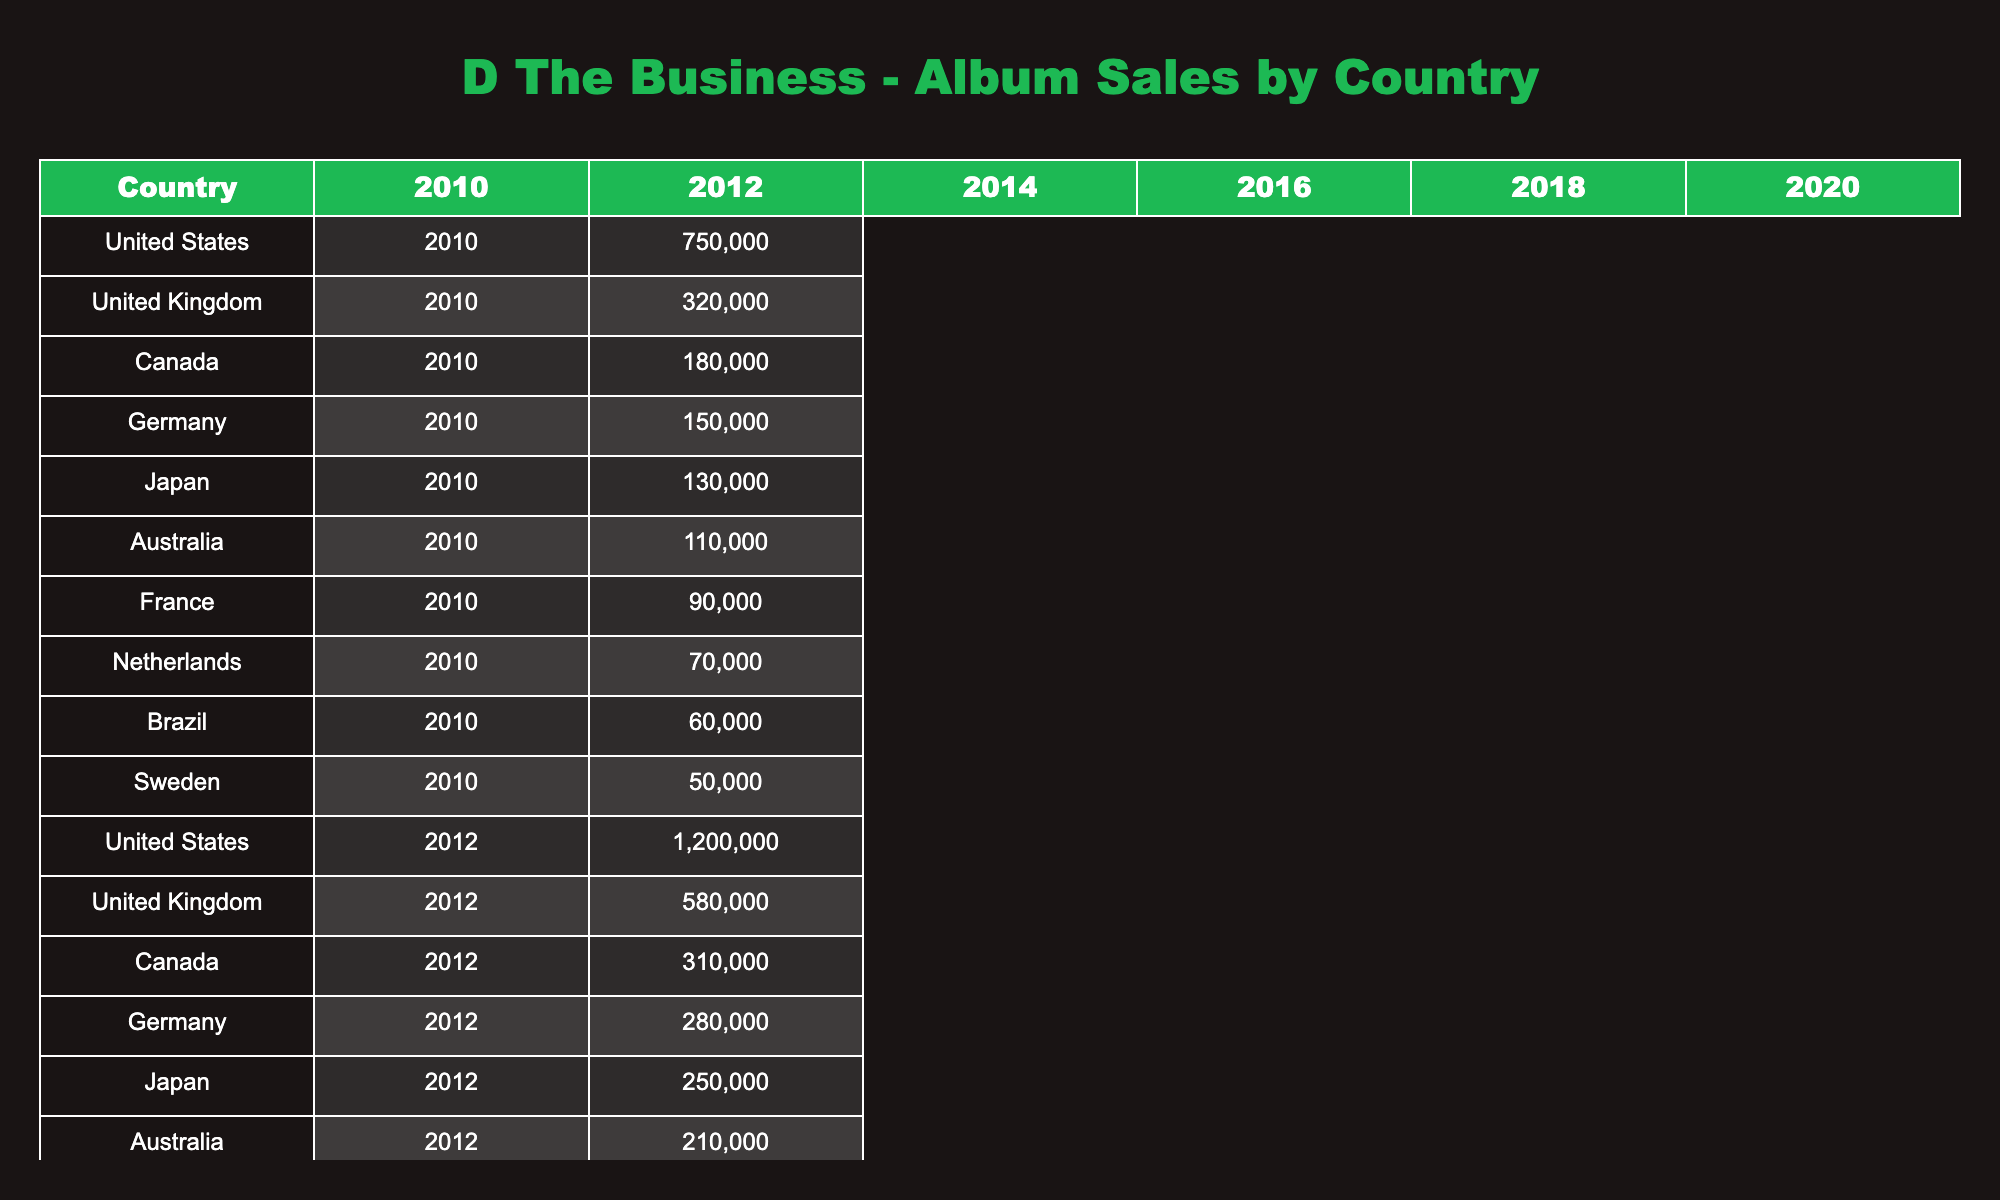What were the album sales figures for D The Business in the United States in 2014? The table indicates that the album sales in the United States in 2014 were 980,000 units.
Answer: 980,000 Which country had the highest album sales in 2012? Referring to the table, the United States had the highest album sales in 2012 with 1,200,000 units.
Answer: United States What is the total album sales for D The Business in Canada over all available years? To find the total, we add the sales figures for Canada: 180,000 + 310,000 + 270,000 + 230,000 + 210,000 + 190,000 = 1,490,000.
Answer: 1,490,000 Did album sales in Australia decrease from 2010 to 2020? Comparing the figures in the table, Australia had sales of 110,000 in 2010 and 130,000 in 2020, indicating an increase.
Answer: No What is the average album sales figure for Germany between 2010 and 2020? We sum the values for Germany: 150,000 + 280,000 + 240,000 + 200,000 + 180,000 + 160,000 = 1,210,000. Then we divide by 6 (the number of years), resulting in an average of approximately 201,667.
Answer: 201,667 In which year did D The Business achieve the lowest album sales in the United Kingdom? The table shows that the lowest album sales in the United Kingdom were in 2018 with 380,000 units sold.
Answer: 2018 How much did album sales increase in the Netherlands from 2010 to 2012? The sales figures in the Netherlands show 70,000 in 2010 and 130,000 in 2012. The increase is 130,000 - 70,000 = 60,000.
Answer: 60,000 Which country consistently had less than 100,000 album sales in at least one year? The table indicates that both Brazil and Sweden had sales figures under 100,000 in 2010.
Answer: Yes What percentage decrease in album sales did Japan experience from 2014 to 2020? The sales in Japan dropped from 220,000 in 2014 to 150,000 in 2020. The decrease is 220,000 - 150,000 = 70,000. The percentage decrease is (70,000 / 220,000) * 100 = 31.82%.
Answer: Approximately 31.82% What was the difference in album sales between the United States and the United Kingdom in the year 2016? In 2016, the United States had 850,000 and the United Kingdom had 410,000. The difference is 850,000 - 410,000 = 440,000.
Answer: 440,000 